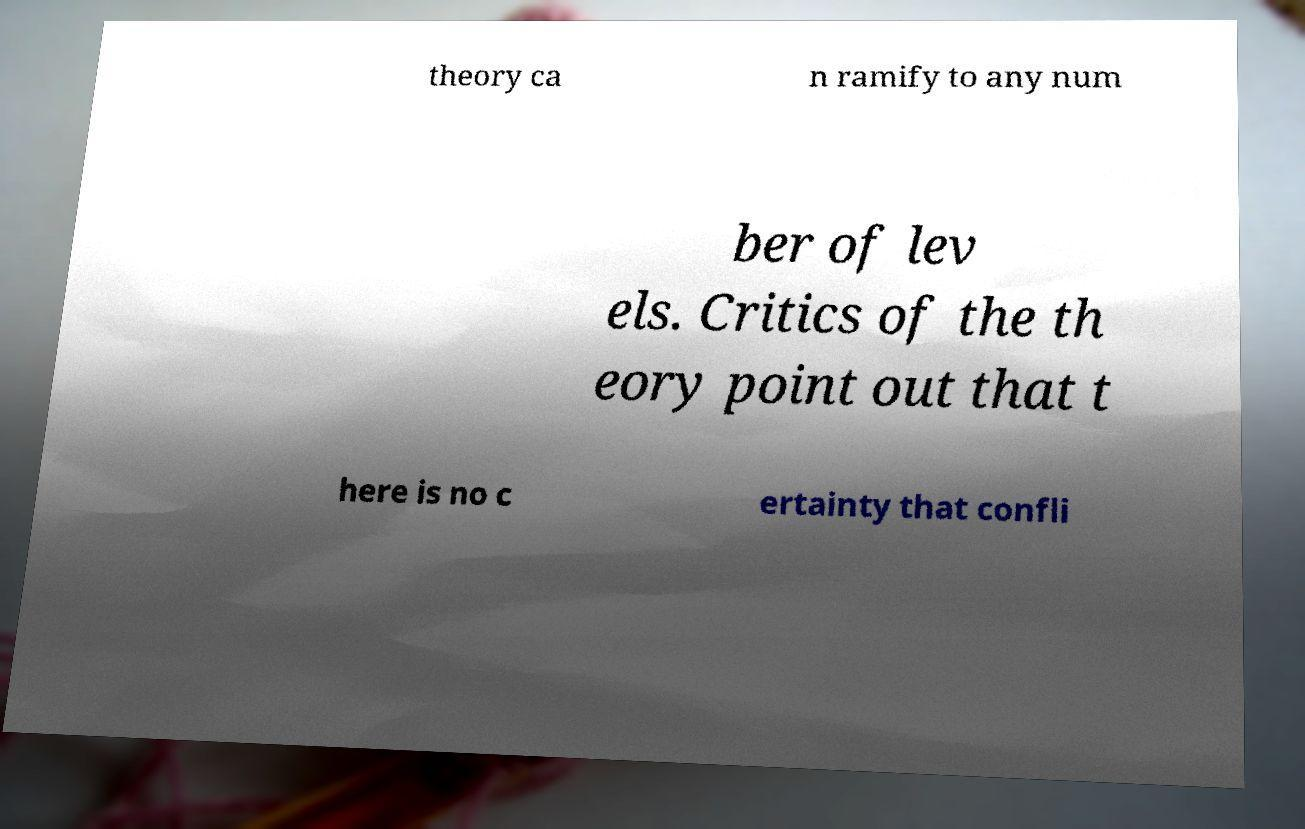For documentation purposes, I need the text within this image transcribed. Could you provide that? theory ca n ramify to any num ber of lev els. Critics of the th eory point out that t here is no c ertainty that confli 